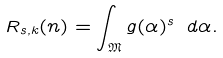<formula> <loc_0><loc_0><loc_500><loc_500>R _ { s , k } ( n ) = \int _ { \mathfrak { M } } g ( \alpha ) ^ { s } \ d \alpha .</formula> 